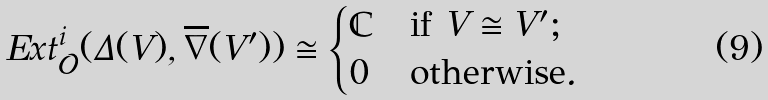<formula> <loc_0><loc_0><loc_500><loc_500>E x t _ { \mathcal { O } } ^ { i } ( { \Delta } ( V ) , \overline { \nabla } ( V ^ { \prime } ) ) \cong \begin{cases} \mathbb { C } & \text {if } V \cong V ^ { \prime } ; \\ 0 & \text {otherwise} . \end{cases}</formula> 